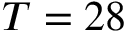Convert formula to latex. <formula><loc_0><loc_0><loc_500><loc_500>T = 2 8</formula> 